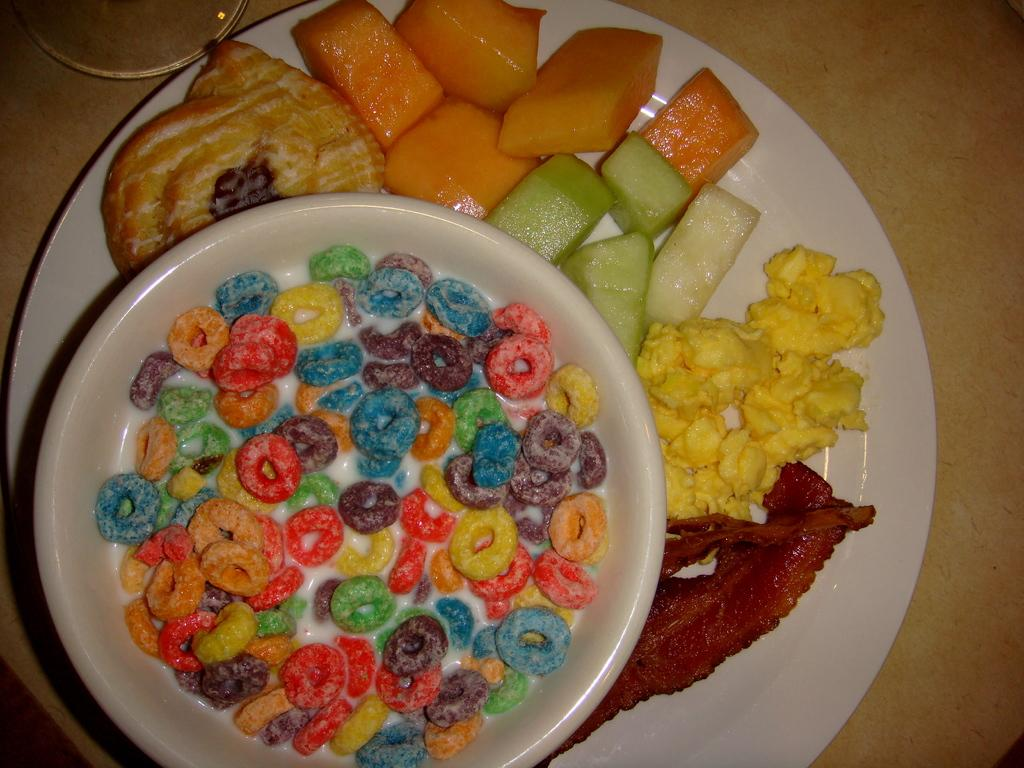What piece of furniture is present in the image? There is a table in the image. How many plates are on the table? There are two plates on the table. What is on the plates? There is food in the plates. What type of badge can be seen on the food in the image? There is no badge present on the food in the image. What kind of horn is visible on the table in the image? There is no horn visible on the table in the image. 